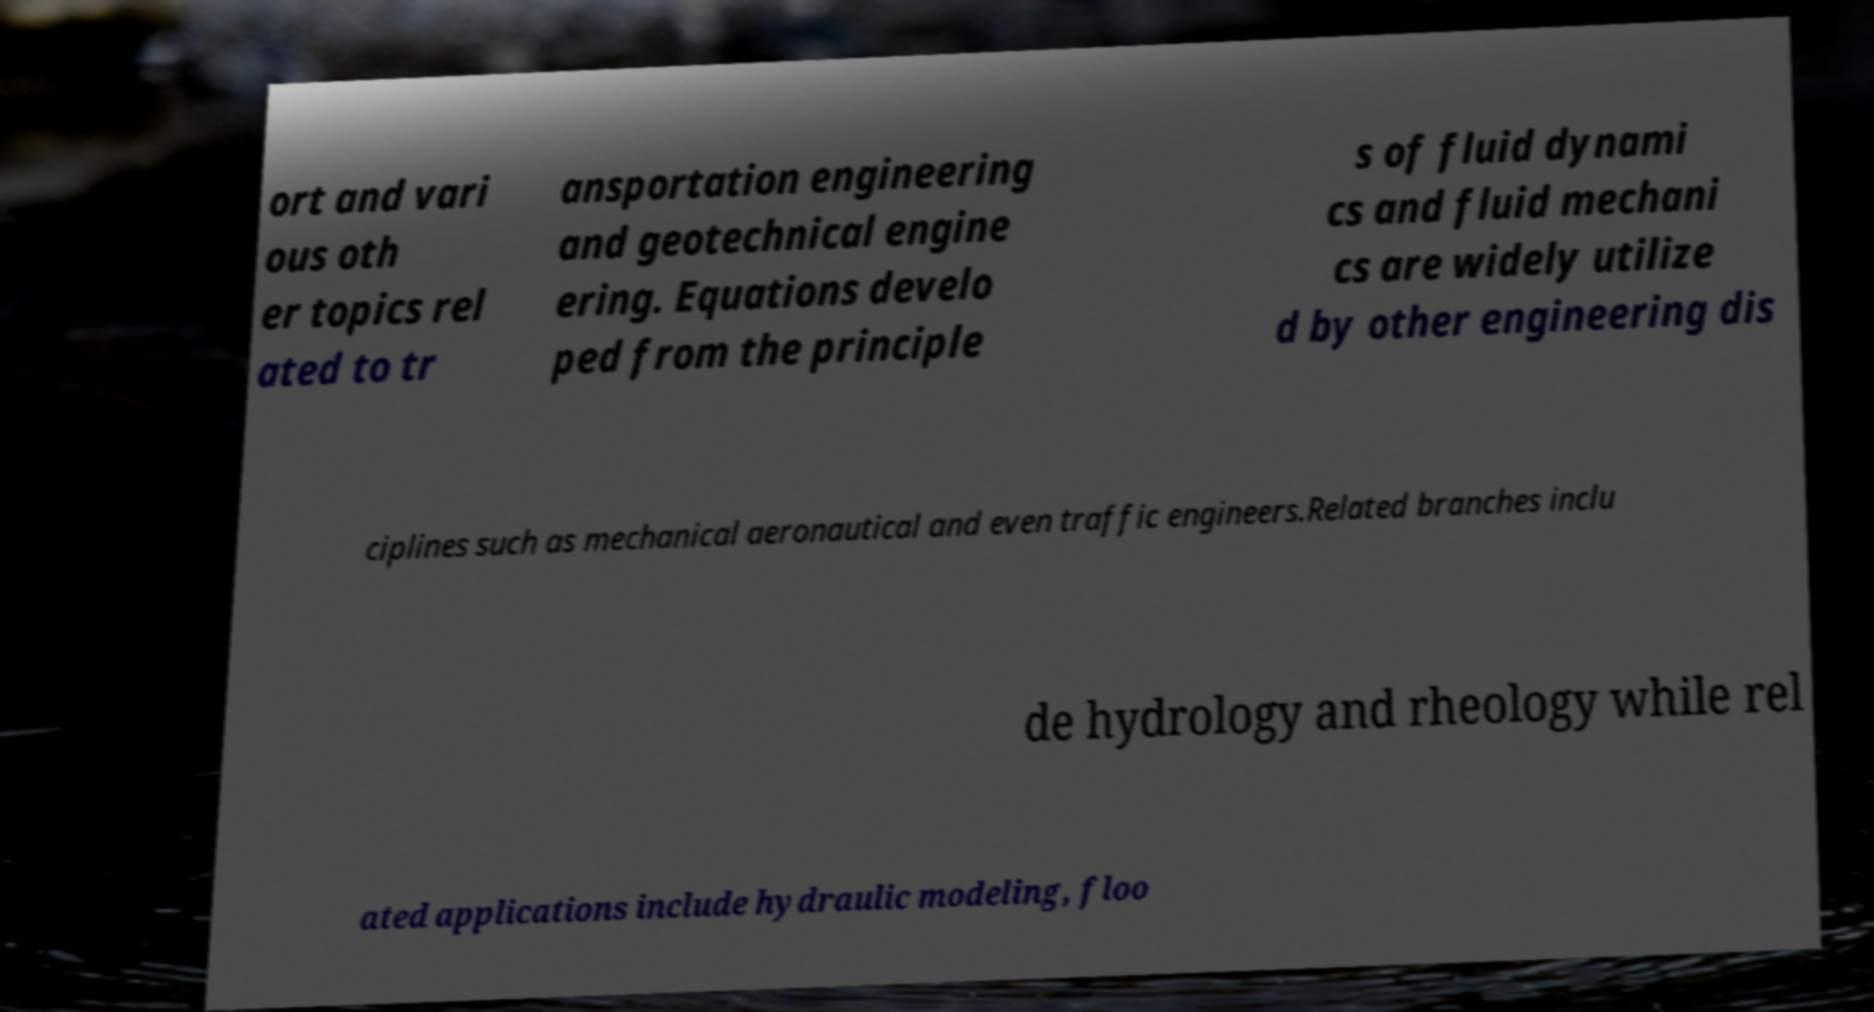Can you accurately transcribe the text from the provided image for me? ort and vari ous oth er topics rel ated to tr ansportation engineering and geotechnical engine ering. Equations develo ped from the principle s of fluid dynami cs and fluid mechani cs are widely utilize d by other engineering dis ciplines such as mechanical aeronautical and even traffic engineers.Related branches inclu de hydrology and rheology while rel ated applications include hydraulic modeling, floo 